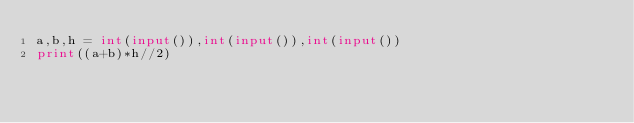Convert code to text. <code><loc_0><loc_0><loc_500><loc_500><_Python_>a,b,h = int(input()),int(input()),int(input())
print((a+b)*h//2)
</code> 